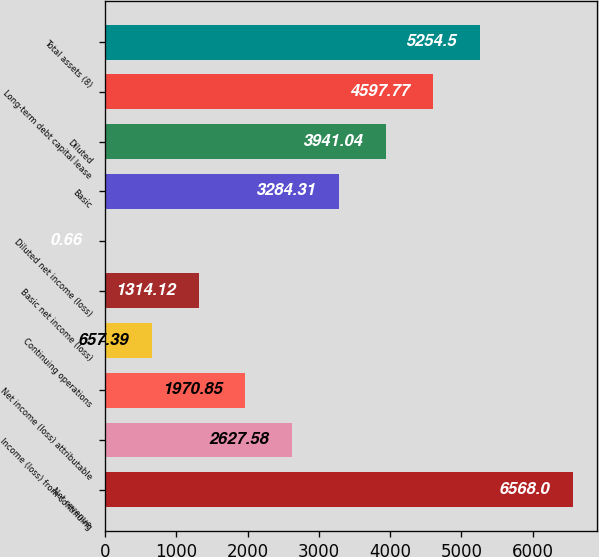<chart> <loc_0><loc_0><loc_500><loc_500><bar_chart><fcel>Net revenue<fcel>Income (loss) from continuing<fcel>Net income (loss) attributable<fcel>Continuing operations<fcel>Basic net income (loss)<fcel>Diluted net income (loss)<fcel>Basic<fcel>Diluted<fcel>Long-term debt capital lease<fcel>Total assets (8)<nl><fcel>6568<fcel>2627.58<fcel>1970.85<fcel>657.39<fcel>1314.12<fcel>0.66<fcel>3284.31<fcel>3941.04<fcel>4597.77<fcel>5254.5<nl></chart> 